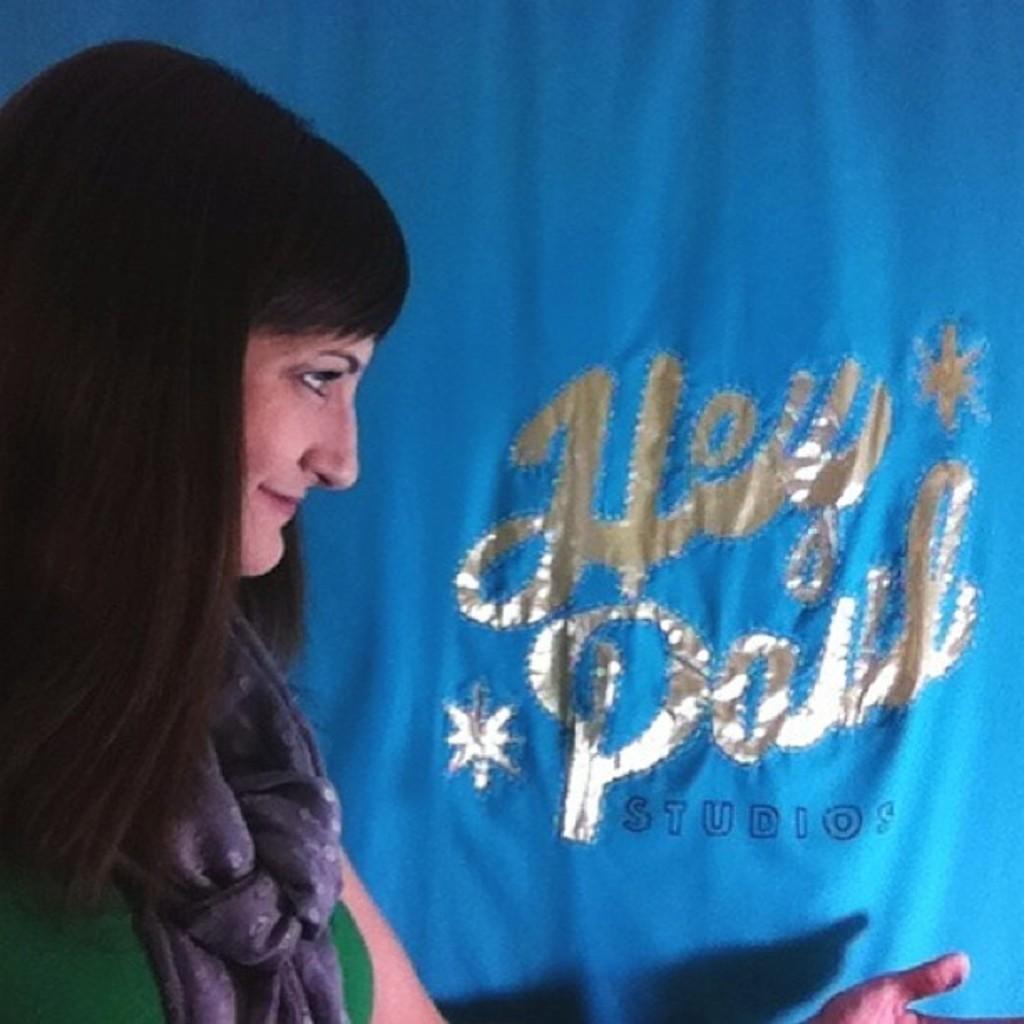Describe this image in one or two sentences. In this image there is a woman who is wearing the scarf is looking at the text which is written on the cloth. 